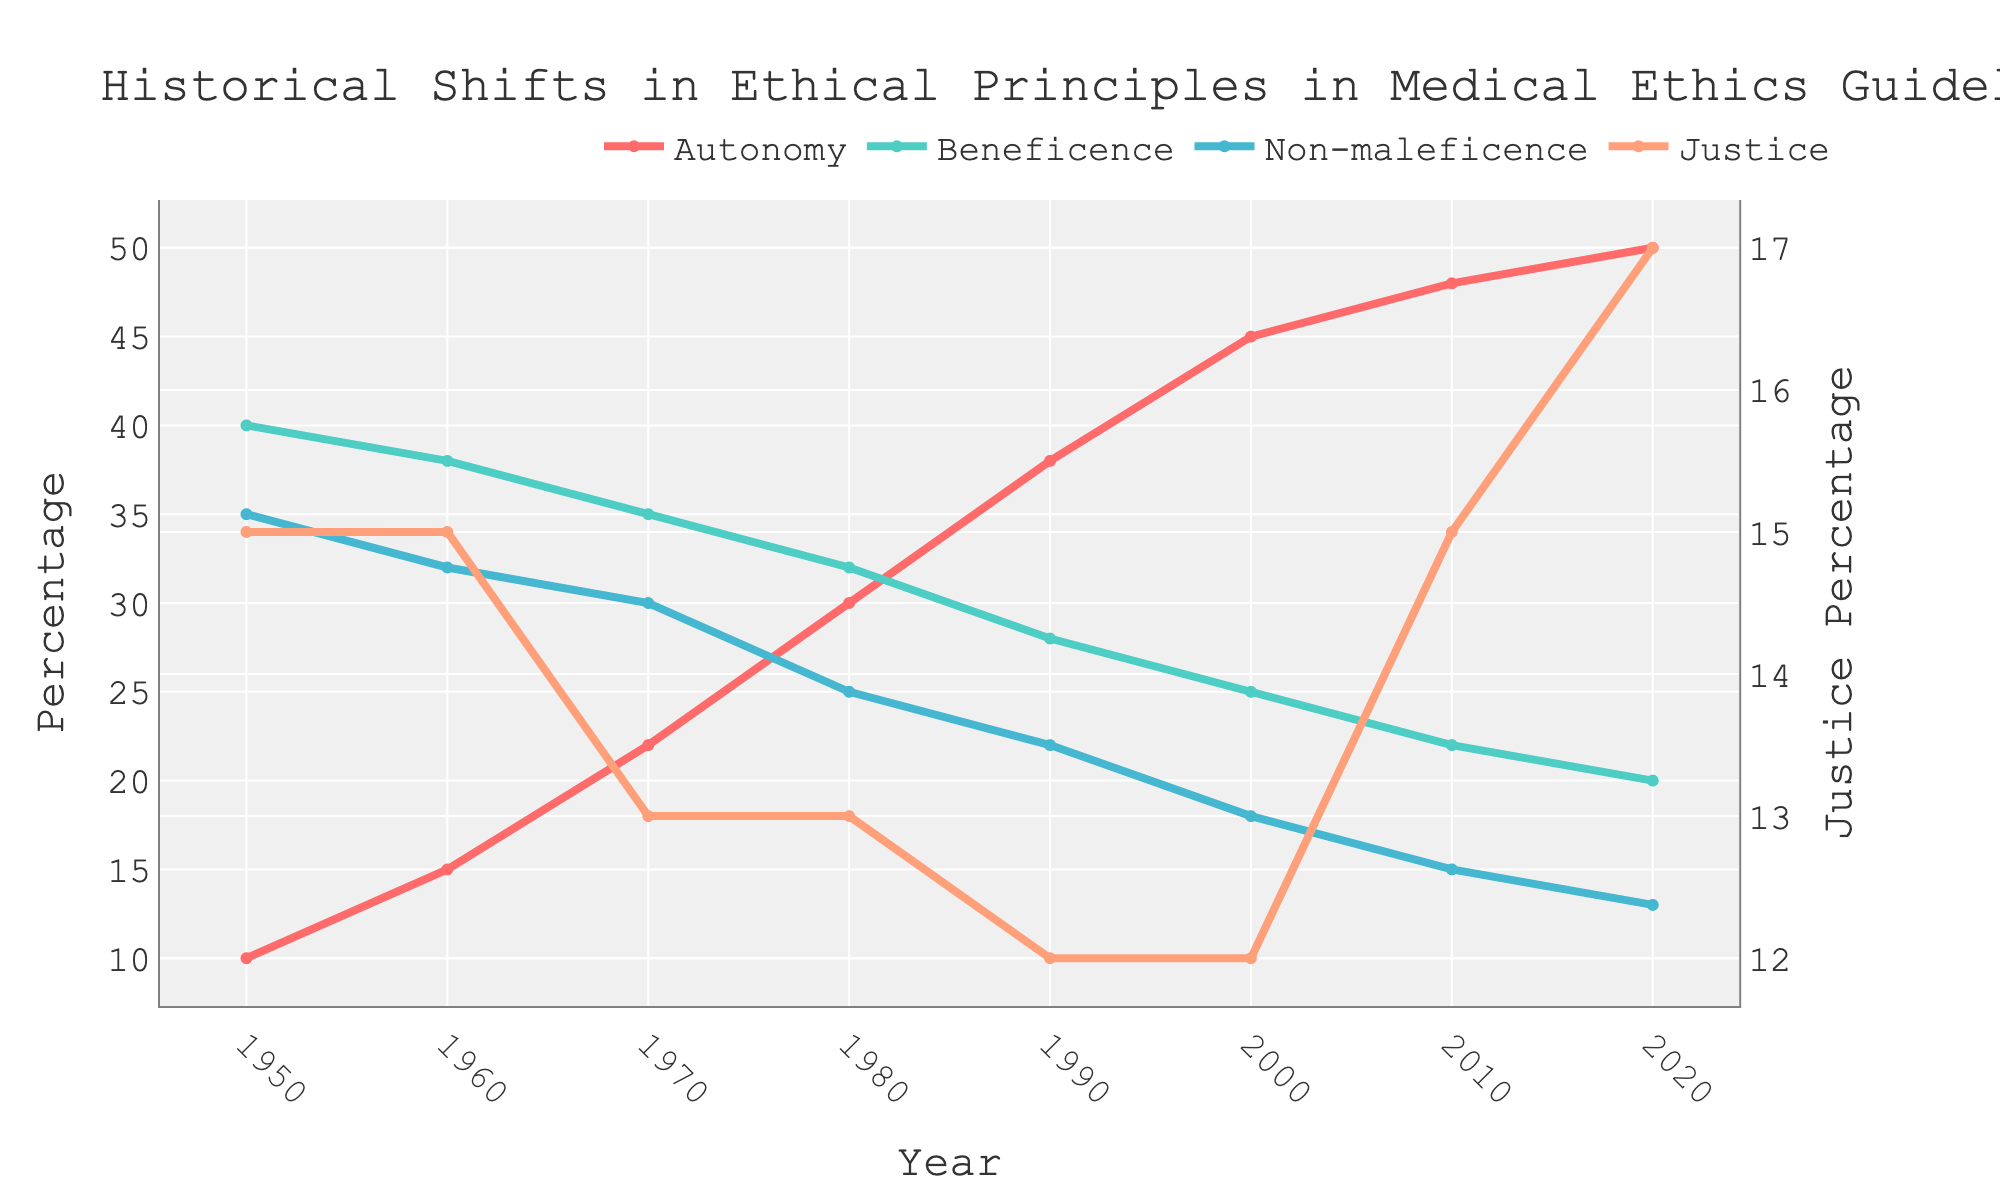Which ethical principle saw the greatest increase in emphasis from 1950 to 2020? To determine which principle saw the greatest increase, look at the initial and final values of each line. Autonomy increased from 10% to 50%, which is the largest gain of 40%.
Answer: Autonomy How did the emphasis on Justice change from 1950 to 2020? Compare the percentage of Justice in 1950 and 2020 by reading the graph values. Justice started at 15% in 1950 and increased to 17% by 2020.
Answer: Increased by 2% Which ethical principle had the highest emphasis in the year 1960? Look at the values on the y-axis for 1960. Beneficence was highest at 38%.
Answer: Beneficence Was there a year when Autonomy and Justice were equal? By checking the values over the years, we see that Autonomy and Justice values are never equal.
Answer: No What is the difference in emphasis on Non-maleficence between 1980 and 2000? Subtract the 2000 value (18%) from the 1980 value (25%). 25% - 18% = 7%.
Answer: 7% Which principle had a decreasing trend throughout the entire period? By observing all trends, Beneficence consistently decreased from 40% in 1950 to 20% in 2020.
Answer: Beneficence In which decade did Autonomy see the largest increase in emphasis? Calculate the differences in Autonomy's values per decade: 1950-1960 (10-15=5), 1960-1970 (15-22=7), 1970-1980 (22-30=8), 1980-1990 (30-38=8), 1990-2000 (38-45=7), 2000-2010 (45-48=3), 2010-2020 (48-50=2). The largest increases are 1970-1980 and 1980-1990, both at 8%.
Answer: 1970-1980 and 1980-1990 Compare the relative changes in Non-maleficence and Justice from 2000 to 2020. Calculate the relative change percentage for both: Non-maleficence (2000-18, 2020-13) (13-18) / 18 * 100 = -27.78%. Justice (2000-12, 2020-17) (17-12) / 12 * 100 = 41.67%.
Answer: Non-maleficence: -27.78%, Justice: 41.67% How many times does the emphasis on Non-maleficence go below 20%? Check the plot points for Non-maleficence below 20% and count them. Values are below 20% in 2000, 2010, and 2020.
Answer: 3 times In 1990, how does the emphasis on Autonomy compare to the combined emphasis on Beneficence and Non-maleficence? Add Beneficence (28%) and Non-maleficence (22%) in 1990, which gives 50%. Compare this to Autonomy (38%). 38% < 50%.
Answer: Less than 